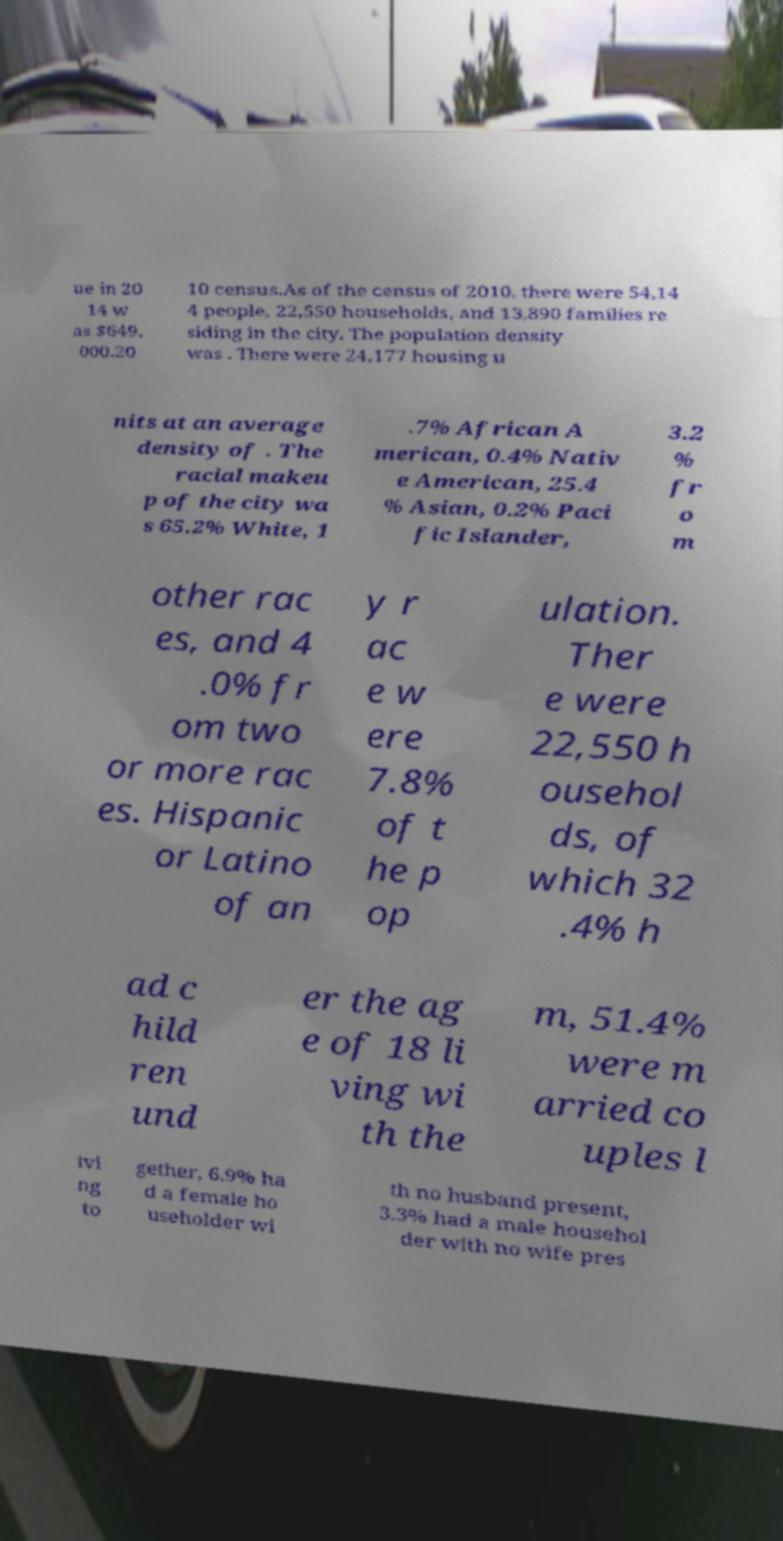Can you accurately transcribe the text from the provided image for me? ue in 20 14 w as $649, 000.20 10 census.As of the census of 2010, there were 54,14 4 people, 22,550 households, and 13,890 families re siding in the city. The population density was . There were 24,177 housing u nits at an average density of . The racial makeu p of the city wa s 65.2% White, 1 .7% African A merican, 0.4% Nativ e American, 25.4 % Asian, 0.2% Paci fic Islander, 3.2 % fr o m other rac es, and 4 .0% fr om two or more rac es. Hispanic or Latino of an y r ac e w ere 7.8% of t he p op ulation. Ther e were 22,550 h ousehol ds, of which 32 .4% h ad c hild ren und er the ag e of 18 li ving wi th the m, 51.4% were m arried co uples l ivi ng to gether, 6.9% ha d a female ho useholder wi th no husband present, 3.3% had a male househol der with no wife pres 